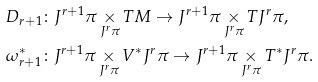Convert formula to latex. <formula><loc_0><loc_0><loc_500><loc_500>& D _ { r + 1 } \colon J ^ { r + 1 } \pi \underset { J ^ { r } \pi } { \times } T M \to J ^ { r + 1 } \pi \underset { J ^ { r } \pi } { \times } T J ^ { r } \pi , \\ & \omega _ { r + 1 } ^ { * } \colon J ^ { r + 1 } \pi \underset { J ^ { r } \pi } { \times } V ^ { * } J ^ { r } \pi \to J ^ { r + 1 } \pi \underset { J ^ { r } \pi } { \times } T ^ { * } J ^ { r } \pi .</formula> 